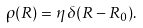<formula> <loc_0><loc_0><loc_500><loc_500>\rho ( R ) = \eta \, \delta ( R - R _ { 0 } ) .</formula> 